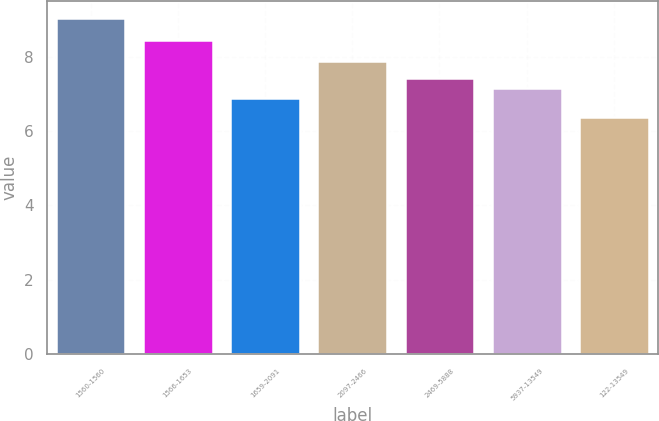Convert chart to OTSL. <chart><loc_0><loc_0><loc_500><loc_500><bar_chart><fcel>1560-1560<fcel>1566-1653<fcel>1659-2091<fcel>2097-2466<fcel>2469-5888<fcel>5937-13549<fcel>122-13549<nl><fcel>9.05<fcel>8.45<fcel>6.89<fcel>7.89<fcel>7.43<fcel>7.16<fcel>6.38<nl></chart> 